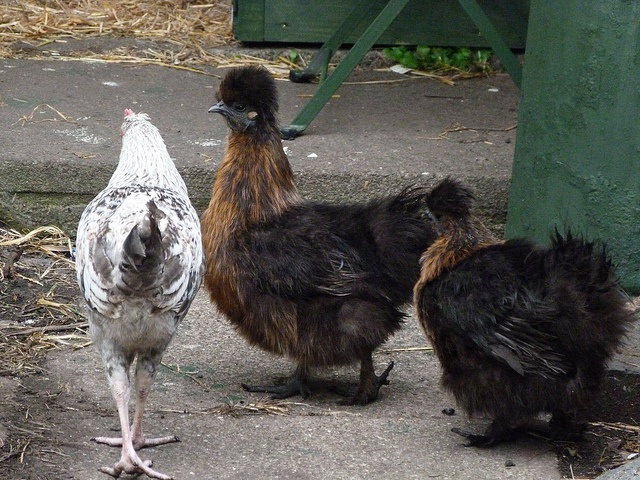Describe the objects in this image and their specific colors. I can see bird in gray, black, and maroon tones, bird in gray, black, and maroon tones, and bird in gray, lightgray, darkgray, and black tones in this image. 